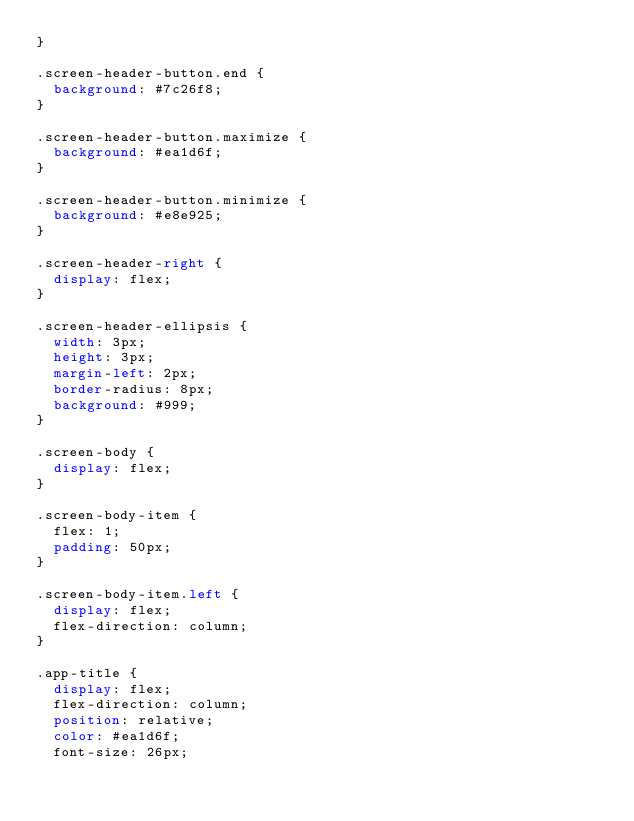<code> <loc_0><loc_0><loc_500><loc_500><_CSS_>}

.screen-header-button.end {
  background: #7c26f8;
}

.screen-header-button.maximize {
  background: #ea1d6f;
}

.screen-header-button.minimize {
  background: #e8e925;
}

.screen-header-right {
  display: flex;
}

.screen-header-ellipsis {
  width: 3px;
  height: 3px;
  margin-left: 2px;
  border-radius: 8px;
  background: #999;
}

.screen-body {
  display: flex;
}

.screen-body-item {
  flex: 1;
  padding: 50px;
}

.screen-body-item.left {
  display: flex;
  flex-direction: column;
}

.app-title {
  display: flex;
  flex-direction: column;
  position: relative;
  color: #ea1d6f;
  font-size: 26px;</code> 